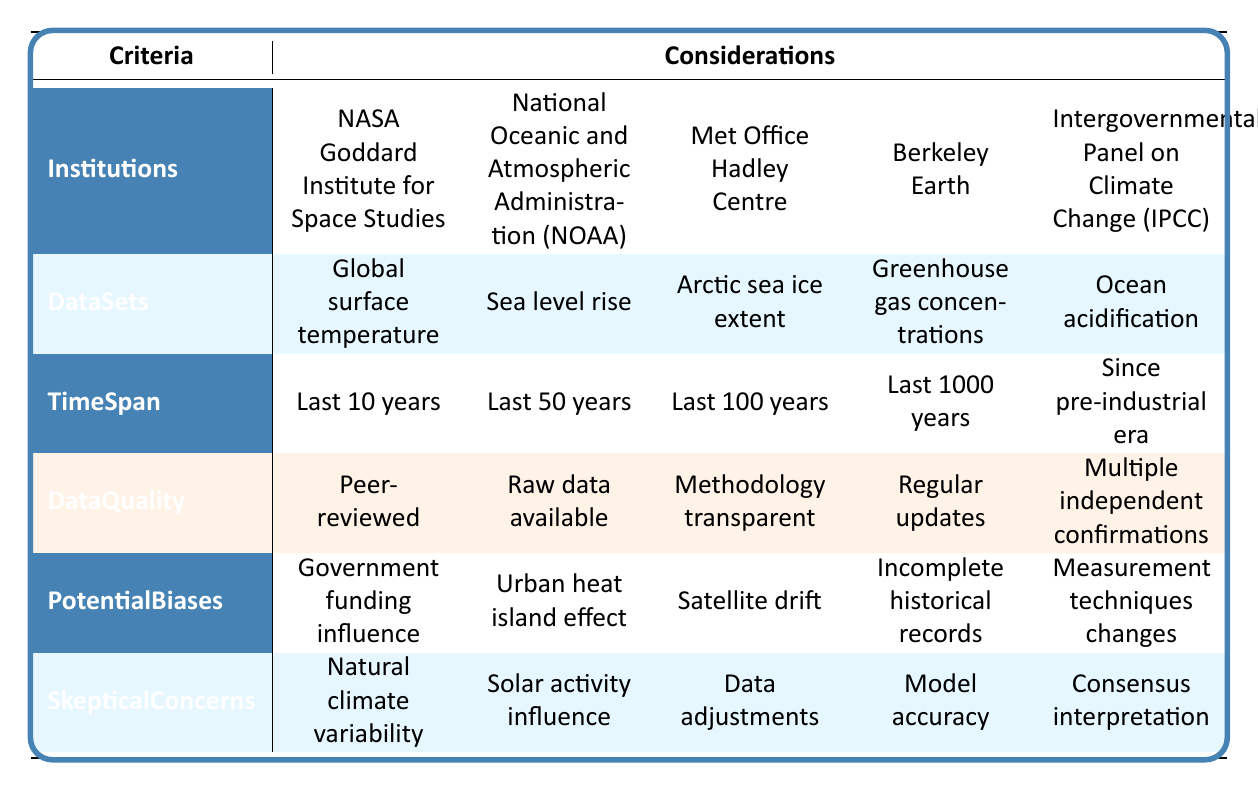What datasets are associated with the Intergovernmental Panel on Climate Change? The table shows that the Intergovernmental Panel on Climate Change is associated with the dataset "Ocean acidification." I directly looked at the row for the IPCC under the DataSets column.
Answer: Ocean acidification Which institution focuses on sea level rise data? The National Oceanic and Atmospheric Administration (NOAA) is listed under the dataset "Sea level rise." This is found by checking the DataSets row corresponding to NOAA.
Answer: National Oceanic and Atmospheric Administration (NOAA) What is the total count of institutions listed in the table? There are five institutions listed in the Institutions row. I simply counted each entry in that row to find the total.
Answer: 5 Is there any institution that provides peer-reviewed data? Yes, the NASA Goddard Institute for Space Studies provides peer-reviewed data, as indicated under the DataQuality row for that institution.
Answer: Yes What is the time span for data from the Met Office Hadley Centre? According to the table, the Met Office Hadley Centre corresponds to the time span of "Last 100 years." This is found by looking at the TimeSpan row for that institution.
Answer: Last 100 years Which datasets are associated with potential biases related to urban heat island effect? The dataset associated with potential biases of the urban heat island effect is not directly indicated in the table, but it specifically relates to the National Oceanic and Atmospheric Administration (NOAA) based on the PotentialBiases row. Combining this information allows for understanding the specific dataset it may relate to.
Answer: National Oceanic and Atmospheric Administration (NOAA) If I wanted comprehensive data quality, which institution would I select? The IPCC provides multiple independent confirmations, which is a strong data quality indicator. By looking at the DataQuality row for IPCC, I see this quality flag. Thus, it is a reasonable choice for comprehensive data.
Answer: Intergovernmental Panel on Climate Change (IPCC) Which institution covers the longest time span for data collection? The institution that covers the longest time span is the Met Office Hadley Centre, focusing on "Last 1000 years" as per the TimeSpan row related to that institution.
Answer: Met Office Hadley Centre 